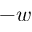<formula> <loc_0><loc_0><loc_500><loc_500>- w</formula> 